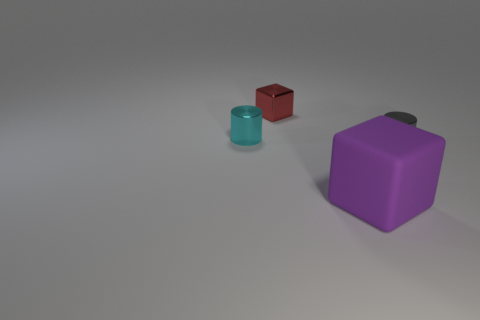Subtract all red blocks. How many blocks are left? 1 Add 2 small blocks. How many objects exist? 6 Subtract all red cylinders. How many red cubes are left? 1 Subtract all tiny cylinders. Subtract all rubber blocks. How many objects are left? 1 Add 2 red metal cubes. How many red metal cubes are left? 3 Add 4 big rubber objects. How many big rubber objects exist? 5 Subtract 0 cyan spheres. How many objects are left? 4 Subtract 1 cubes. How many cubes are left? 1 Subtract all cyan cylinders. Subtract all brown balls. How many cylinders are left? 1 